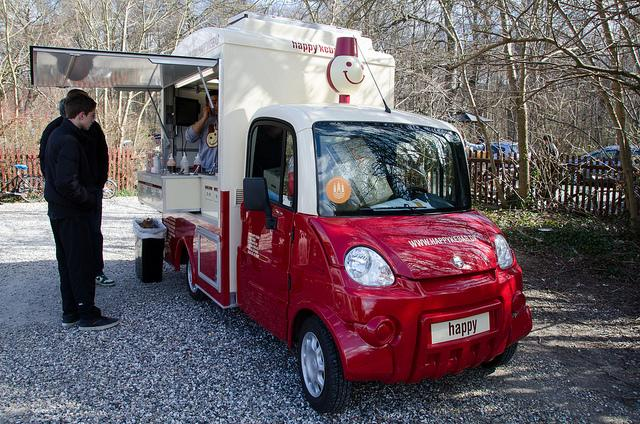Where could someone put their garbage? trash can 